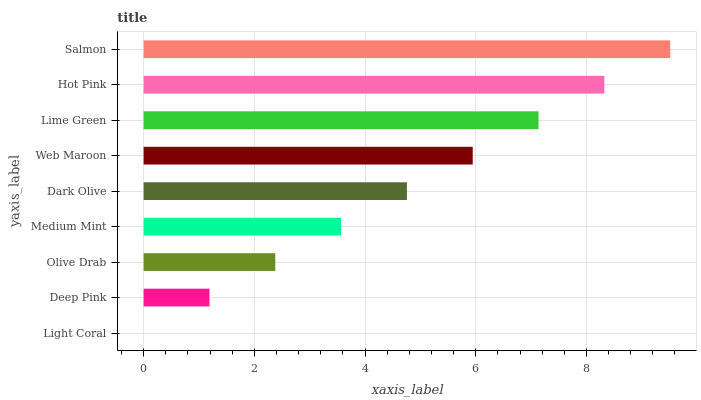Is Light Coral the minimum?
Answer yes or no. Yes. Is Salmon the maximum?
Answer yes or no. Yes. Is Deep Pink the minimum?
Answer yes or no. No. Is Deep Pink the maximum?
Answer yes or no. No. Is Deep Pink greater than Light Coral?
Answer yes or no. Yes. Is Light Coral less than Deep Pink?
Answer yes or no. Yes. Is Light Coral greater than Deep Pink?
Answer yes or no. No. Is Deep Pink less than Light Coral?
Answer yes or no. No. Is Dark Olive the high median?
Answer yes or no. Yes. Is Dark Olive the low median?
Answer yes or no. Yes. Is Medium Mint the high median?
Answer yes or no. No. Is Olive Drab the low median?
Answer yes or no. No. 